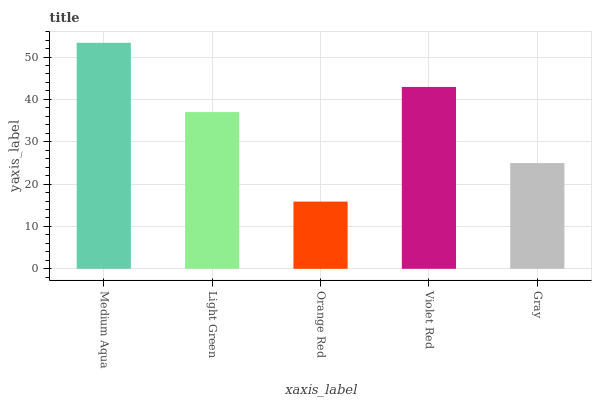Is Light Green the minimum?
Answer yes or no. No. Is Light Green the maximum?
Answer yes or no. No. Is Medium Aqua greater than Light Green?
Answer yes or no. Yes. Is Light Green less than Medium Aqua?
Answer yes or no. Yes. Is Light Green greater than Medium Aqua?
Answer yes or no. No. Is Medium Aqua less than Light Green?
Answer yes or no. No. Is Light Green the high median?
Answer yes or no. Yes. Is Light Green the low median?
Answer yes or no. Yes. Is Gray the high median?
Answer yes or no. No. Is Violet Red the low median?
Answer yes or no. No. 